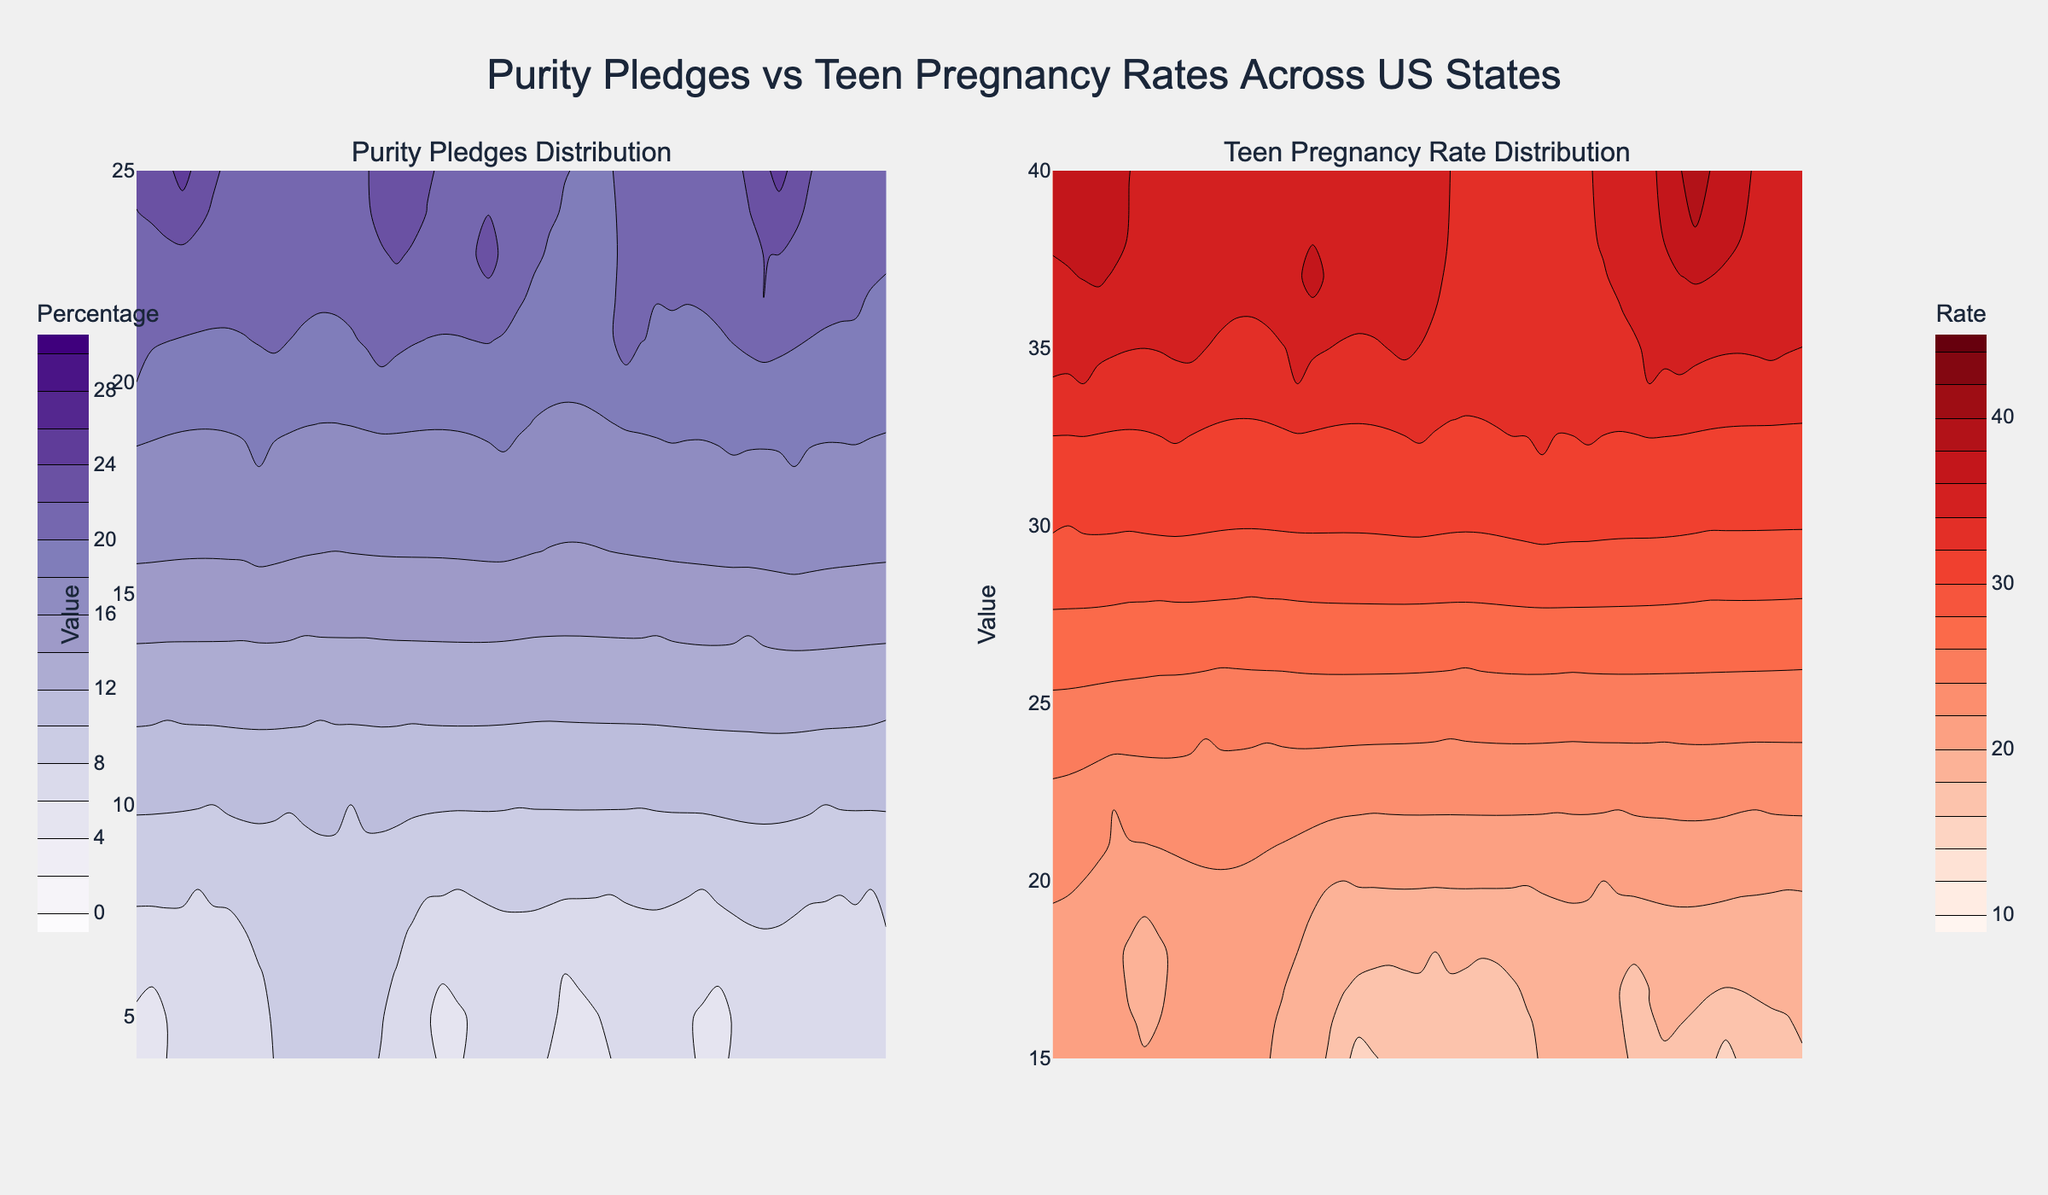What is the color scale used for representing the purity pledge percentage? The contour plot representing the purity pledge percentage uses a 'Purples' color scale. This can be observed from the varying shades of purple used in the left plot.
Answer: Purples What is the highest contour value for the teen pregnancy rate? The highest contour value for the teen pregnancy rate is 45. This is specified in the contour interval setup where the contours start at 10 and end at 45.
Answer: 45 Which subplot shows the distribution of the purity pledges? The distribution of purity pledges is shown in the subplot on the left. This can be identified by looking at the title of the subplot which reads "Purity Pledges Distribution".
Answer: Left Subplot What state has the highest percentage of purity pledges and what color represents it? Texas has the highest percentage of purity pledges at 25%, and it is represented by the darkest shade of purple on the left subplot.
Answer: Texas, darkest purple Compare the teen pregnancy rates between states with high and low purity pledge percentages. To answer this question, we need to look at the distribution of both high and low purity pledges on the left contour plot and match these areas to the corresponding color intensities on the right contour plot. States with high purity percentages like Texas (darkest purple) show high teen pregnancy rates (darkest red), while states with low purity percentages like Massachusetts (lightest purple) show lower teen pregnancy rates (lightest red).
Answer: Higher purity pledges often correlate with higher teen pregnancy rates How does the color intensity for teen pregnancy rates in states with 20% purity pledge compare to those with 5% purity pledge? States with 20% purity pledge (e.g., Alabama) are represented with darker reds in the right subplot, indicating higher pregnancy rates, while states with 5% purity pledge (e.g., Alaska) have lighter reds, indicating lower pregnancy rates.
Answer: Darker for 20%, lighter for 5% What can be inferred about the relationship between purity pledge percentages and teen pregnancy rates? The contour plots suggest a potential positive correlation where states with higher purity pledge percentages tend to have higher teen pregnancy rates. This is inferred by comparing the color intensities on the two subplots, where darker purples (higher purity pledges) often correspond to darker reds (higher teen pregnancy rates).
Answer: Positive correlation How many states have a purity pledge percentage equal to or greater than 20%? By examining the contour levels and the data points plotted, we find that there are 8 states with purity pledge percentages equal to or exceeding 20%, indicated by the darker regions in the left subplot.
Answer: 8 Which color bar denotes the contour intervals for the purity pledge percentage, and how is it positioned? The color bar for the purity pledge percentage is in shades of purple, and it is positioned to the left of the left subplot title with contours starting from 0 to 30.
Answer: Positioned left, Purples color bar Are there any states where the teen pregnancy rate is below 20%? If so, how many states have such rates? Yes, there are states where the teen pregnancy rate is below 20%. These states can be identified in the right subplot by locating the areas with the lightest red shades. On counting these areas, there are 9 states with teen pregnancy rates under 20%.
Answer: 9 